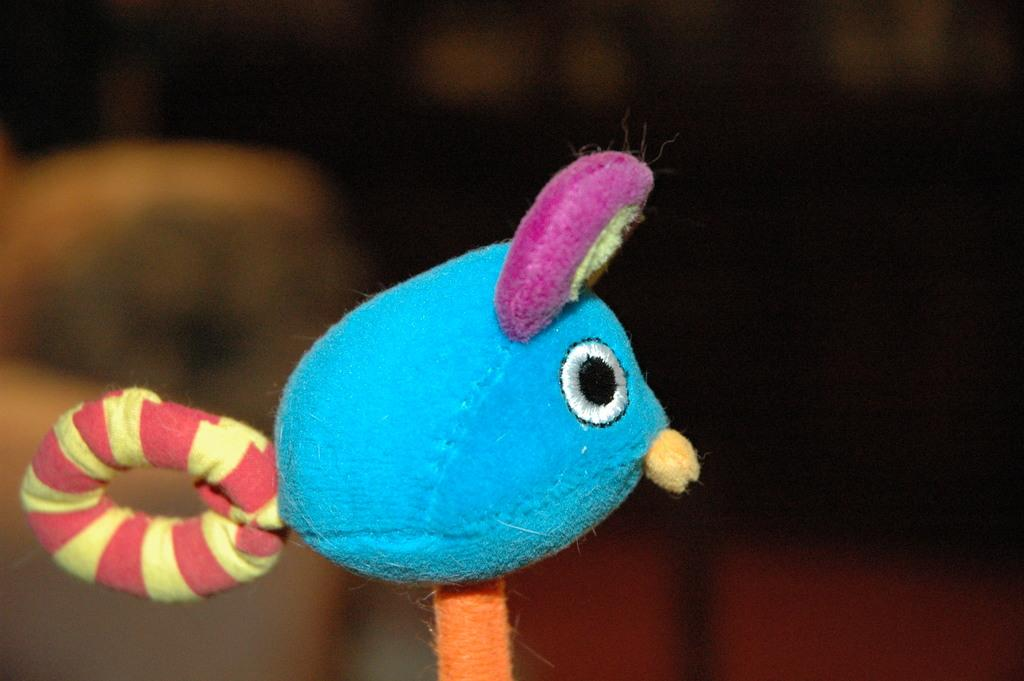What object is located in the front of the image? There is a toy in the front of the image. Can you describe the background of the image? The background of the image is blurry. What type of distribution system is visible in the image? There is no distribution system present in the image. Can you see any trails left by a vehicle in the image? There are no trails left by a vehicle in the image. 